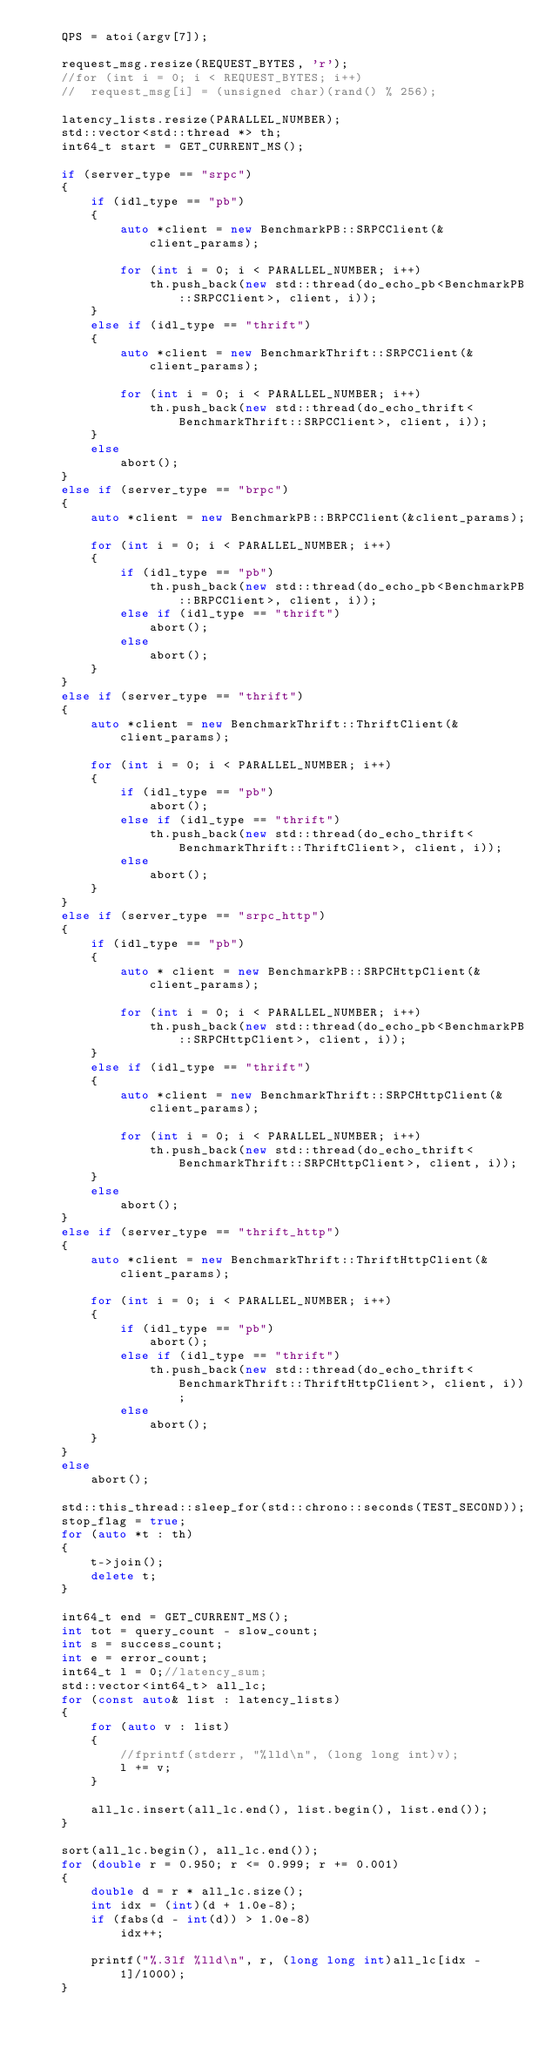Convert code to text. <code><loc_0><loc_0><loc_500><loc_500><_C++_>	QPS = atoi(argv[7]);

	request_msg.resize(REQUEST_BYTES, 'r');
	//for (int i = 0; i < REQUEST_BYTES; i++)
	//	request_msg[i] = (unsigned char)(rand() % 256);

	latency_lists.resize(PARALLEL_NUMBER);
	std::vector<std::thread *> th;
	int64_t start = GET_CURRENT_MS();

	if (server_type == "srpc")
	{
		if (idl_type == "pb")
		{
			auto *client = new BenchmarkPB::SRPCClient(&client_params);

			for (int i = 0; i < PARALLEL_NUMBER; i++)
				th.push_back(new std::thread(do_echo_pb<BenchmarkPB::SRPCClient>, client, i));
		}
		else if (idl_type == "thrift")
		{
			auto *client = new BenchmarkThrift::SRPCClient(&client_params);

			for (int i = 0; i < PARALLEL_NUMBER; i++)
				th.push_back(new std::thread(do_echo_thrift<BenchmarkThrift::SRPCClient>, client, i));
		}
		else
			abort();
	}
	else if (server_type == "brpc")
	{
		auto *client = new BenchmarkPB::BRPCClient(&client_params);

		for (int i = 0; i < PARALLEL_NUMBER; i++)
		{
			if (idl_type == "pb")
				th.push_back(new std::thread(do_echo_pb<BenchmarkPB::BRPCClient>, client, i));
			else if (idl_type == "thrift")
				abort();
			else
				abort();
		}
	}
	else if (server_type == "thrift")
	{
		auto *client = new BenchmarkThrift::ThriftClient(&client_params);

		for (int i = 0; i < PARALLEL_NUMBER; i++)
		{
			if (idl_type == "pb")
				abort();
			else if (idl_type == "thrift")
				th.push_back(new std::thread(do_echo_thrift<BenchmarkThrift::ThriftClient>, client, i));
			else
				abort();
		}
	}
	else if (server_type == "srpc_http")
	{
		if (idl_type == "pb")
		{
			auto * client = new BenchmarkPB::SRPCHttpClient(&client_params);

			for (int i = 0; i < PARALLEL_NUMBER; i++)
				th.push_back(new std::thread(do_echo_pb<BenchmarkPB::SRPCHttpClient>, client, i));
		}
		else if (idl_type == "thrift")
		{
			auto *client = new BenchmarkThrift::SRPCHttpClient(&client_params);

			for (int i = 0; i < PARALLEL_NUMBER; i++)
				th.push_back(new std::thread(do_echo_thrift<BenchmarkThrift::SRPCHttpClient>, client, i));
		}
		else
			abort();
	}
	else if (server_type == "thrift_http")
	{
		auto *client = new BenchmarkThrift::ThriftHttpClient(&client_params);

		for (int i = 0; i < PARALLEL_NUMBER; i++)
		{
			if (idl_type == "pb")
				abort();
			else if (idl_type == "thrift")
				th.push_back(new std::thread(do_echo_thrift<BenchmarkThrift::ThriftHttpClient>, client, i));
			else
				abort();
		}
	}
	else
		abort();

	std::this_thread::sleep_for(std::chrono::seconds(TEST_SECOND));
	stop_flag = true;
	for (auto *t : th)
	{
		t->join();
		delete t;
	}

	int64_t end = GET_CURRENT_MS();
	int tot = query_count - slow_count;
	int s = success_count;
	int e = error_count;
	int64_t l = 0;//latency_sum;
	std::vector<int64_t> all_lc;
	for (const auto& list : latency_lists)
	{
		for (auto v : list)
		{
			//fprintf(stderr, "%lld\n", (long long int)v);
			l += v;
		}

		all_lc.insert(all_lc.end(), list.begin(), list.end());
	}

	sort(all_lc.begin(), all_lc.end());
	for (double r = 0.950; r <= 0.999; r += 0.001)
	{
		double d = r * all_lc.size();
		int idx = (int)(d + 1.0e-8);
		if (fabs(d - int(d)) > 1.0e-8)
			idx++;

		printf("%.3lf %lld\n", r, (long long int)all_lc[idx - 1]/1000);
	}
</code> 